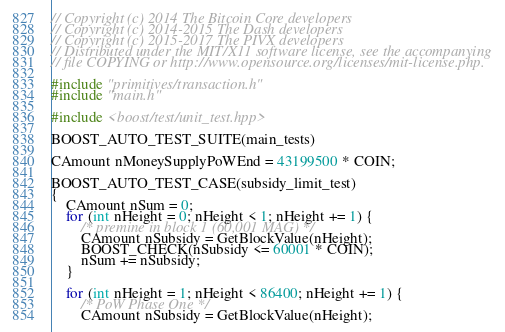<code> <loc_0><loc_0><loc_500><loc_500><_C++_>// Copyright (c) 2014 The Bitcoin Core developers
// Copyright (c) 2014-2015 The Dash developers
// Copyright (c) 2015-2017 The PIVX developers
// Distributed under the MIT/X11 software license, see the accompanying
// file COPYING or http://www.opensource.org/licenses/mit-license.php.

#include "primitives/transaction.h"
#include "main.h"

#include <boost/test/unit_test.hpp>

BOOST_AUTO_TEST_SUITE(main_tests)

CAmount nMoneySupplyPoWEnd = 43199500 * COIN;

BOOST_AUTO_TEST_CASE(subsidy_limit_test)
{
    CAmount nSum = 0;
    for (int nHeight = 0; nHeight < 1; nHeight += 1) {
        /* premine in block 1 (60,001 MAG) */
        CAmount nSubsidy = GetBlockValue(nHeight);
        BOOST_CHECK(nSubsidy <= 60001 * COIN);
        nSum += nSubsidy;
    }

    for (int nHeight = 1; nHeight < 86400; nHeight += 1) {
        /* PoW Phase One */
        CAmount nSubsidy = GetBlockValue(nHeight);</code> 